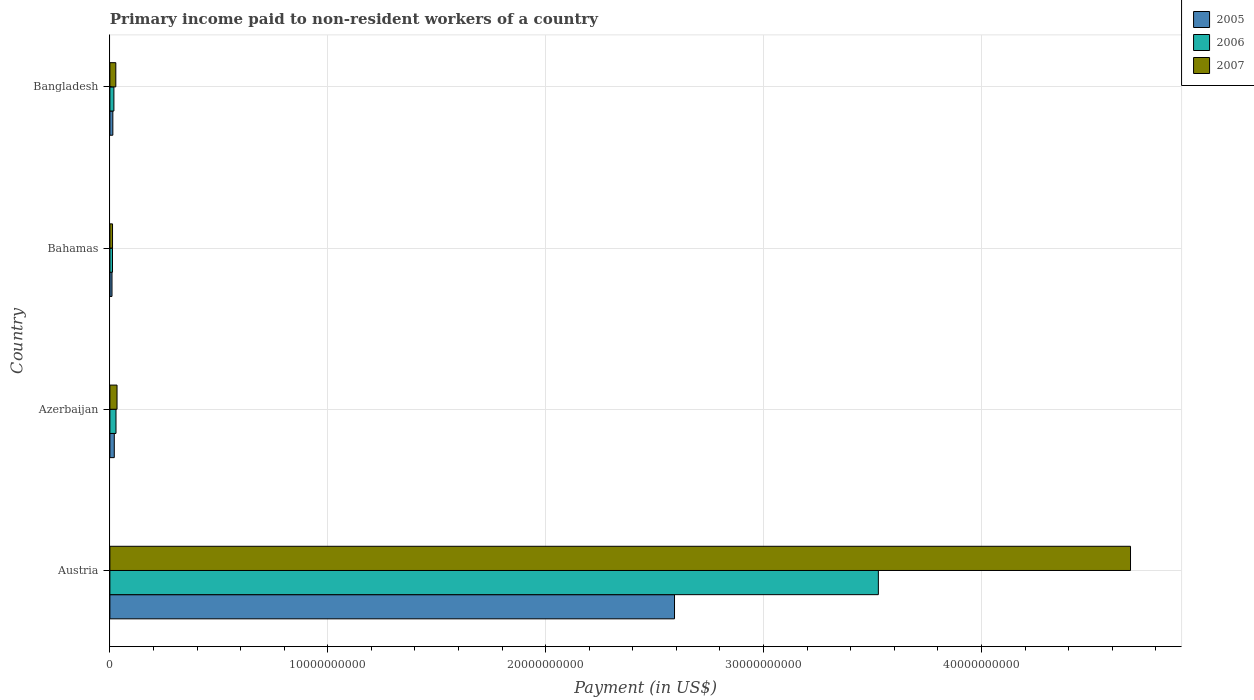Are the number of bars on each tick of the Y-axis equal?
Your answer should be compact. Yes. How many bars are there on the 3rd tick from the bottom?
Provide a succinct answer. 3. What is the label of the 3rd group of bars from the top?
Your answer should be very brief. Azerbaijan. In how many cases, is the number of bars for a given country not equal to the number of legend labels?
Provide a succinct answer. 0. What is the amount paid to workers in 2006 in Bahamas?
Provide a succinct answer. 1.19e+08. Across all countries, what is the maximum amount paid to workers in 2005?
Your answer should be compact. 2.59e+1. Across all countries, what is the minimum amount paid to workers in 2007?
Your answer should be very brief. 1.21e+08. In which country was the amount paid to workers in 2005 minimum?
Give a very brief answer. Bahamas. What is the total amount paid to workers in 2007 in the graph?
Your answer should be compact. 4.76e+1. What is the difference between the amount paid to workers in 2005 in Bahamas and that in Bangladesh?
Offer a very short reply. -3.82e+07. What is the difference between the amount paid to workers in 2007 in Bahamas and the amount paid to workers in 2006 in Bangladesh?
Your answer should be compact. -6.32e+07. What is the average amount paid to workers in 2006 per country?
Ensure brevity in your answer.  8.96e+09. What is the difference between the amount paid to workers in 2005 and amount paid to workers in 2007 in Austria?
Keep it short and to the point. -2.09e+1. What is the ratio of the amount paid to workers in 2005 in Azerbaijan to that in Bahamas?
Offer a very short reply. 2.08. Is the difference between the amount paid to workers in 2005 in Azerbaijan and Bahamas greater than the difference between the amount paid to workers in 2007 in Azerbaijan and Bahamas?
Offer a terse response. No. What is the difference between the highest and the second highest amount paid to workers in 2005?
Give a very brief answer. 2.57e+1. What is the difference between the highest and the lowest amount paid to workers in 2007?
Your answer should be compact. 4.67e+1. Is the sum of the amount paid to workers in 2007 in Azerbaijan and Bangladesh greater than the maximum amount paid to workers in 2006 across all countries?
Keep it short and to the point. No. What does the 2nd bar from the top in Bahamas represents?
Provide a succinct answer. 2006. Is it the case that in every country, the sum of the amount paid to workers in 2006 and amount paid to workers in 2005 is greater than the amount paid to workers in 2007?
Provide a short and direct response. Yes. Are the values on the major ticks of X-axis written in scientific E-notation?
Provide a succinct answer. No. Does the graph contain any zero values?
Give a very brief answer. No. Where does the legend appear in the graph?
Your answer should be very brief. Top right. How are the legend labels stacked?
Ensure brevity in your answer.  Vertical. What is the title of the graph?
Your response must be concise. Primary income paid to non-resident workers of a country. Does "2000" appear as one of the legend labels in the graph?
Your answer should be compact. No. What is the label or title of the X-axis?
Give a very brief answer. Payment (in US$). What is the Payment (in US$) of 2005 in Austria?
Provide a short and direct response. 2.59e+1. What is the Payment (in US$) of 2006 in Austria?
Your answer should be compact. 3.53e+1. What is the Payment (in US$) of 2007 in Austria?
Keep it short and to the point. 4.68e+1. What is the Payment (in US$) of 2005 in Azerbaijan?
Offer a very short reply. 2.02e+08. What is the Payment (in US$) of 2006 in Azerbaijan?
Offer a very short reply. 2.80e+08. What is the Payment (in US$) in 2007 in Azerbaijan?
Your answer should be very brief. 3.28e+08. What is the Payment (in US$) of 2005 in Bahamas?
Offer a very short reply. 9.70e+07. What is the Payment (in US$) of 2006 in Bahamas?
Provide a short and direct response. 1.19e+08. What is the Payment (in US$) in 2007 in Bahamas?
Offer a very short reply. 1.21e+08. What is the Payment (in US$) of 2005 in Bangladesh?
Your answer should be compact. 1.35e+08. What is the Payment (in US$) of 2006 in Bangladesh?
Your response must be concise. 1.84e+08. What is the Payment (in US$) of 2007 in Bangladesh?
Offer a very short reply. 2.72e+08. Across all countries, what is the maximum Payment (in US$) of 2005?
Provide a short and direct response. 2.59e+1. Across all countries, what is the maximum Payment (in US$) of 2006?
Offer a very short reply. 3.53e+1. Across all countries, what is the maximum Payment (in US$) in 2007?
Provide a succinct answer. 4.68e+1. Across all countries, what is the minimum Payment (in US$) in 2005?
Your response must be concise. 9.70e+07. Across all countries, what is the minimum Payment (in US$) in 2006?
Offer a terse response. 1.19e+08. Across all countries, what is the minimum Payment (in US$) of 2007?
Provide a short and direct response. 1.21e+08. What is the total Payment (in US$) of 2005 in the graph?
Give a very brief answer. 2.63e+1. What is the total Payment (in US$) in 2006 in the graph?
Keep it short and to the point. 3.59e+1. What is the total Payment (in US$) of 2007 in the graph?
Keep it short and to the point. 4.76e+1. What is the difference between the Payment (in US$) in 2005 in Austria and that in Azerbaijan?
Offer a very short reply. 2.57e+1. What is the difference between the Payment (in US$) of 2006 in Austria and that in Azerbaijan?
Give a very brief answer. 3.50e+1. What is the difference between the Payment (in US$) in 2007 in Austria and that in Azerbaijan?
Offer a very short reply. 4.65e+1. What is the difference between the Payment (in US$) in 2005 in Austria and that in Bahamas?
Offer a terse response. 2.58e+1. What is the difference between the Payment (in US$) in 2006 in Austria and that in Bahamas?
Your answer should be very brief. 3.52e+1. What is the difference between the Payment (in US$) in 2007 in Austria and that in Bahamas?
Provide a short and direct response. 4.67e+1. What is the difference between the Payment (in US$) of 2005 in Austria and that in Bangladesh?
Provide a short and direct response. 2.58e+1. What is the difference between the Payment (in US$) of 2006 in Austria and that in Bangladesh?
Give a very brief answer. 3.51e+1. What is the difference between the Payment (in US$) in 2007 in Austria and that in Bangladesh?
Provide a succinct answer. 4.66e+1. What is the difference between the Payment (in US$) of 2005 in Azerbaijan and that in Bahamas?
Your response must be concise. 1.05e+08. What is the difference between the Payment (in US$) of 2006 in Azerbaijan and that in Bahamas?
Keep it short and to the point. 1.61e+08. What is the difference between the Payment (in US$) in 2007 in Azerbaijan and that in Bahamas?
Offer a very short reply. 2.07e+08. What is the difference between the Payment (in US$) in 2005 in Azerbaijan and that in Bangladesh?
Make the answer very short. 6.66e+07. What is the difference between the Payment (in US$) of 2006 in Azerbaijan and that in Bangladesh?
Your response must be concise. 9.56e+07. What is the difference between the Payment (in US$) in 2007 in Azerbaijan and that in Bangladesh?
Ensure brevity in your answer.  5.61e+07. What is the difference between the Payment (in US$) in 2005 in Bahamas and that in Bangladesh?
Give a very brief answer. -3.82e+07. What is the difference between the Payment (in US$) of 2006 in Bahamas and that in Bangladesh?
Offer a very short reply. -6.50e+07. What is the difference between the Payment (in US$) of 2007 in Bahamas and that in Bangladesh?
Your response must be concise. -1.50e+08. What is the difference between the Payment (in US$) of 2005 in Austria and the Payment (in US$) of 2006 in Azerbaijan?
Offer a terse response. 2.56e+1. What is the difference between the Payment (in US$) in 2005 in Austria and the Payment (in US$) in 2007 in Azerbaijan?
Provide a succinct answer. 2.56e+1. What is the difference between the Payment (in US$) of 2006 in Austria and the Payment (in US$) of 2007 in Azerbaijan?
Ensure brevity in your answer.  3.49e+1. What is the difference between the Payment (in US$) in 2005 in Austria and the Payment (in US$) in 2006 in Bahamas?
Ensure brevity in your answer.  2.58e+1. What is the difference between the Payment (in US$) of 2005 in Austria and the Payment (in US$) of 2007 in Bahamas?
Your answer should be compact. 2.58e+1. What is the difference between the Payment (in US$) in 2006 in Austria and the Payment (in US$) in 2007 in Bahamas?
Offer a very short reply. 3.51e+1. What is the difference between the Payment (in US$) in 2005 in Austria and the Payment (in US$) in 2006 in Bangladesh?
Make the answer very short. 2.57e+1. What is the difference between the Payment (in US$) in 2005 in Austria and the Payment (in US$) in 2007 in Bangladesh?
Give a very brief answer. 2.56e+1. What is the difference between the Payment (in US$) of 2006 in Austria and the Payment (in US$) of 2007 in Bangladesh?
Keep it short and to the point. 3.50e+1. What is the difference between the Payment (in US$) of 2005 in Azerbaijan and the Payment (in US$) of 2006 in Bahamas?
Your response must be concise. 8.24e+07. What is the difference between the Payment (in US$) in 2005 in Azerbaijan and the Payment (in US$) in 2007 in Bahamas?
Your answer should be very brief. 8.05e+07. What is the difference between the Payment (in US$) in 2006 in Azerbaijan and the Payment (in US$) in 2007 in Bahamas?
Offer a very short reply. 1.59e+08. What is the difference between the Payment (in US$) of 2005 in Azerbaijan and the Payment (in US$) of 2006 in Bangladesh?
Your response must be concise. 1.74e+07. What is the difference between the Payment (in US$) in 2005 in Azerbaijan and the Payment (in US$) in 2007 in Bangladesh?
Make the answer very short. -6.99e+07. What is the difference between the Payment (in US$) in 2006 in Azerbaijan and the Payment (in US$) in 2007 in Bangladesh?
Make the answer very short. 8.32e+06. What is the difference between the Payment (in US$) of 2005 in Bahamas and the Payment (in US$) of 2006 in Bangladesh?
Offer a terse response. -8.74e+07. What is the difference between the Payment (in US$) of 2005 in Bahamas and the Payment (in US$) of 2007 in Bangladesh?
Offer a terse response. -1.75e+08. What is the difference between the Payment (in US$) of 2006 in Bahamas and the Payment (in US$) of 2007 in Bangladesh?
Ensure brevity in your answer.  -1.52e+08. What is the average Payment (in US$) of 2005 per country?
Ensure brevity in your answer.  6.59e+09. What is the average Payment (in US$) in 2006 per country?
Keep it short and to the point. 8.96e+09. What is the average Payment (in US$) of 2007 per country?
Provide a succinct answer. 1.19e+1. What is the difference between the Payment (in US$) in 2005 and Payment (in US$) in 2006 in Austria?
Offer a very short reply. -9.36e+09. What is the difference between the Payment (in US$) in 2005 and Payment (in US$) in 2007 in Austria?
Make the answer very short. -2.09e+1. What is the difference between the Payment (in US$) of 2006 and Payment (in US$) of 2007 in Austria?
Keep it short and to the point. -1.16e+1. What is the difference between the Payment (in US$) in 2005 and Payment (in US$) in 2006 in Azerbaijan?
Your response must be concise. -7.82e+07. What is the difference between the Payment (in US$) in 2005 and Payment (in US$) in 2007 in Azerbaijan?
Give a very brief answer. -1.26e+08. What is the difference between the Payment (in US$) in 2006 and Payment (in US$) in 2007 in Azerbaijan?
Your answer should be very brief. -4.78e+07. What is the difference between the Payment (in US$) of 2005 and Payment (in US$) of 2006 in Bahamas?
Your answer should be compact. -2.24e+07. What is the difference between the Payment (in US$) in 2005 and Payment (in US$) in 2007 in Bahamas?
Your response must be concise. -2.43e+07. What is the difference between the Payment (in US$) in 2006 and Payment (in US$) in 2007 in Bahamas?
Make the answer very short. -1.88e+06. What is the difference between the Payment (in US$) in 2005 and Payment (in US$) in 2006 in Bangladesh?
Offer a very short reply. -4.93e+07. What is the difference between the Payment (in US$) in 2005 and Payment (in US$) in 2007 in Bangladesh?
Offer a very short reply. -1.37e+08. What is the difference between the Payment (in US$) of 2006 and Payment (in US$) of 2007 in Bangladesh?
Give a very brief answer. -8.73e+07. What is the ratio of the Payment (in US$) of 2005 in Austria to that in Azerbaijan?
Ensure brevity in your answer.  128.41. What is the ratio of the Payment (in US$) of 2006 in Austria to that in Azerbaijan?
Offer a very short reply. 125.96. What is the ratio of the Payment (in US$) of 2007 in Austria to that in Azerbaijan?
Provide a short and direct response. 142.91. What is the ratio of the Payment (in US$) of 2005 in Austria to that in Bahamas?
Offer a terse response. 267.18. What is the ratio of the Payment (in US$) of 2006 in Austria to that in Bahamas?
Provide a short and direct response. 295.41. What is the ratio of the Payment (in US$) of 2007 in Austria to that in Bahamas?
Your response must be concise. 386.27. What is the ratio of the Payment (in US$) in 2005 in Austria to that in Bangladesh?
Offer a very short reply. 191.72. What is the ratio of the Payment (in US$) of 2006 in Austria to that in Bangladesh?
Offer a very short reply. 191.23. What is the ratio of the Payment (in US$) of 2007 in Austria to that in Bangladesh?
Your response must be concise. 172.41. What is the ratio of the Payment (in US$) in 2005 in Azerbaijan to that in Bahamas?
Provide a succinct answer. 2.08. What is the ratio of the Payment (in US$) in 2006 in Azerbaijan to that in Bahamas?
Give a very brief answer. 2.35. What is the ratio of the Payment (in US$) in 2007 in Azerbaijan to that in Bahamas?
Ensure brevity in your answer.  2.7. What is the ratio of the Payment (in US$) of 2005 in Azerbaijan to that in Bangladesh?
Offer a very short reply. 1.49. What is the ratio of the Payment (in US$) in 2006 in Azerbaijan to that in Bangladesh?
Your answer should be compact. 1.52. What is the ratio of the Payment (in US$) in 2007 in Azerbaijan to that in Bangladesh?
Offer a terse response. 1.21. What is the ratio of the Payment (in US$) in 2005 in Bahamas to that in Bangladesh?
Give a very brief answer. 0.72. What is the ratio of the Payment (in US$) of 2006 in Bahamas to that in Bangladesh?
Your answer should be very brief. 0.65. What is the ratio of the Payment (in US$) in 2007 in Bahamas to that in Bangladesh?
Make the answer very short. 0.45. What is the difference between the highest and the second highest Payment (in US$) of 2005?
Your response must be concise. 2.57e+1. What is the difference between the highest and the second highest Payment (in US$) of 2006?
Keep it short and to the point. 3.50e+1. What is the difference between the highest and the second highest Payment (in US$) of 2007?
Provide a short and direct response. 4.65e+1. What is the difference between the highest and the lowest Payment (in US$) of 2005?
Keep it short and to the point. 2.58e+1. What is the difference between the highest and the lowest Payment (in US$) of 2006?
Ensure brevity in your answer.  3.52e+1. What is the difference between the highest and the lowest Payment (in US$) in 2007?
Offer a very short reply. 4.67e+1. 